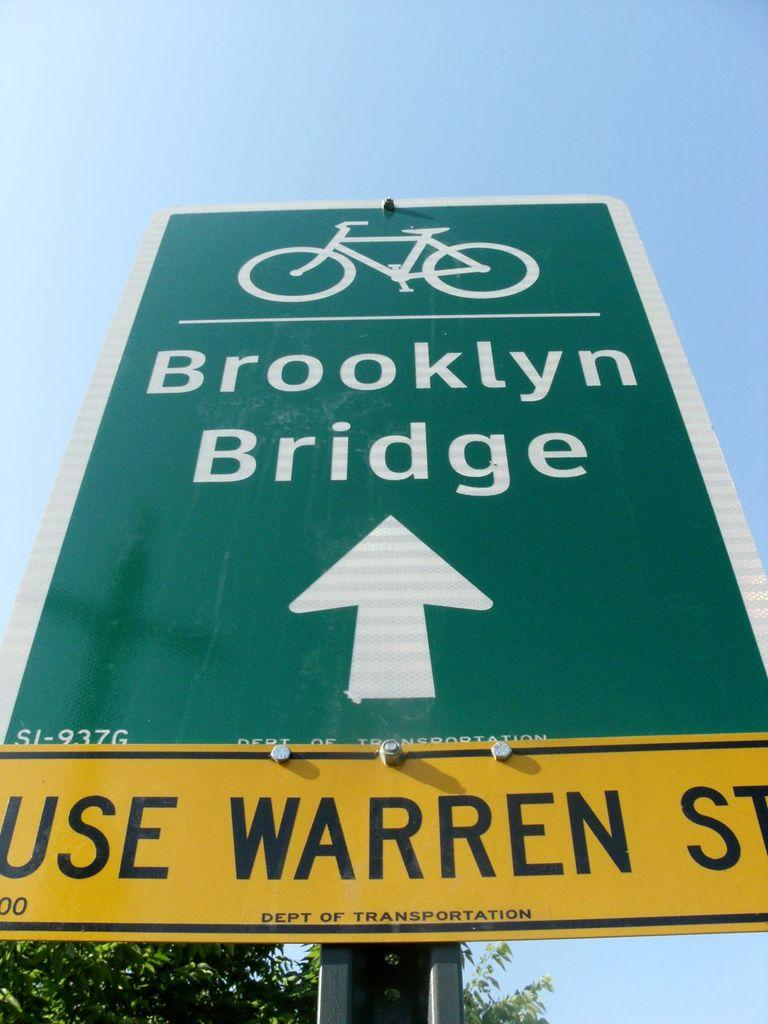What is the main object in the image? There is a sign board in the image. What can be seen in the background of the image? The sky is visible in the background of the image. What type of vegetation is present at the bottom of the image? Leaves are present at the bottom of the image. What direction is the wrench pointing towards in the image? There is no wrench present in the image. Can you describe the spot on the sign board where the leaves are touching it? There is no spot on the sign board where the leaves are touching it; the leaves are simply present at the bottom of the image. 